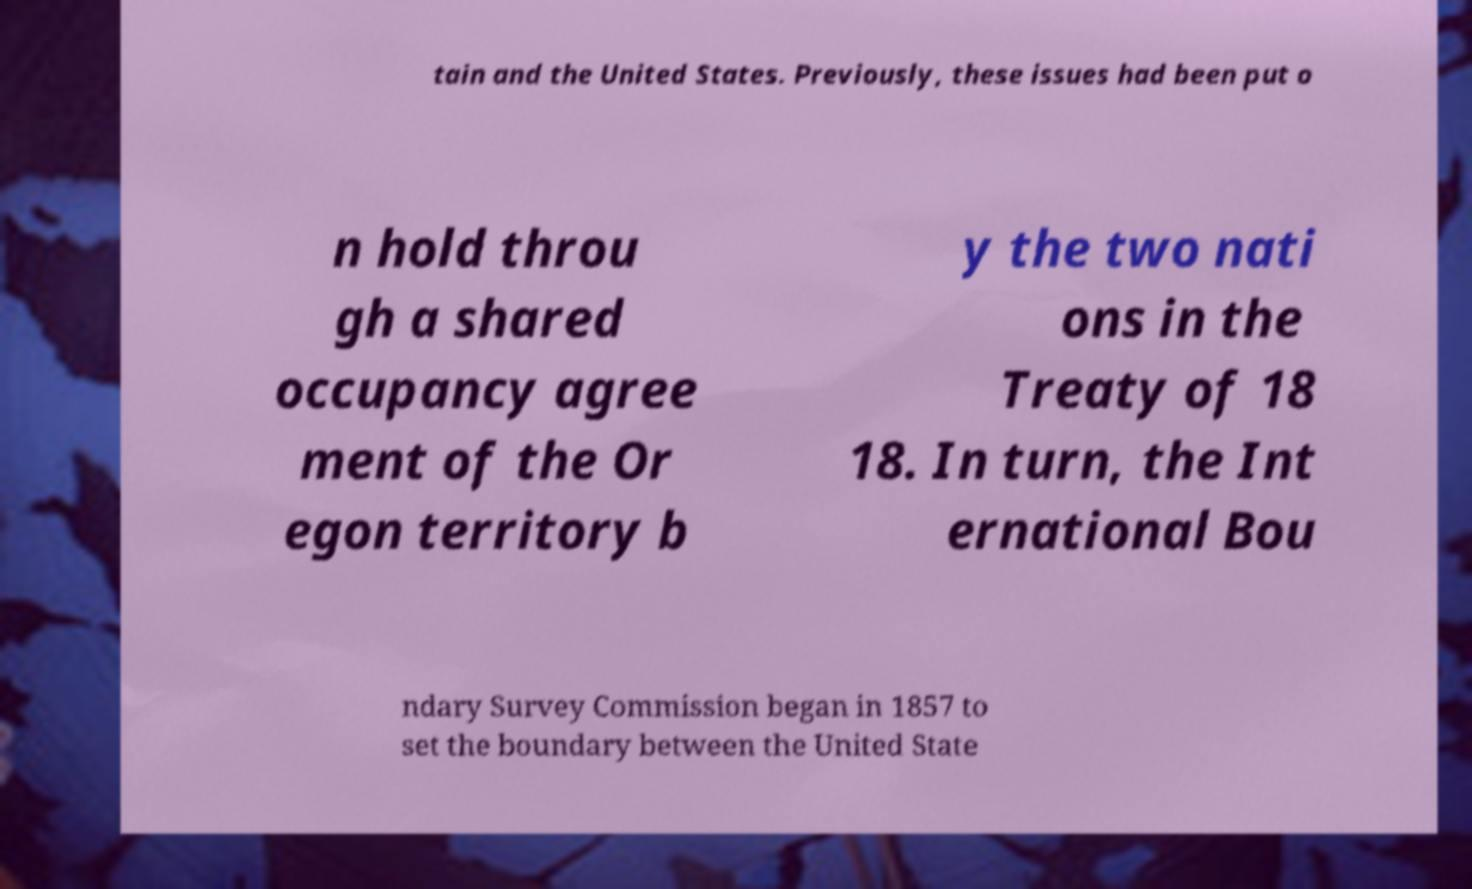What messages or text are displayed in this image? I need them in a readable, typed format. tain and the United States. Previously, these issues had been put o n hold throu gh a shared occupancy agree ment of the Or egon territory b y the two nati ons in the Treaty of 18 18. In turn, the Int ernational Bou ndary Survey Commission began in 1857 to set the boundary between the United State 